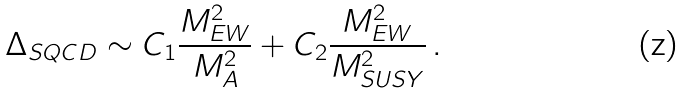<formula> <loc_0><loc_0><loc_500><loc_500>\Delta _ { S Q C D } \sim C _ { 1 } \frac { M _ { E W } ^ { 2 } } { M _ { A } ^ { 2 } } + C _ { 2 } \frac { M _ { E W } ^ { 2 } } { M _ { S U S Y } ^ { 2 } } \, .</formula> 